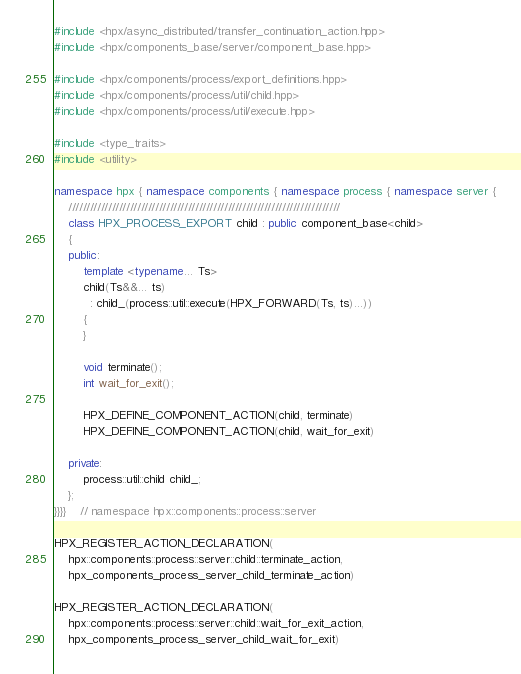Convert code to text. <code><loc_0><loc_0><loc_500><loc_500><_C++_>#include <hpx/async_distributed/transfer_continuation_action.hpp>
#include <hpx/components_base/server/component_base.hpp>

#include <hpx/components/process/export_definitions.hpp>
#include <hpx/components/process/util/child.hpp>
#include <hpx/components/process/util/execute.hpp>

#include <type_traits>
#include <utility>

namespace hpx { namespace components { namespace process { namespace server {
    ///////////////////////////////////////////////////////////////////////////
    class HPX_PROCESS_EXPORT child : public component_base<child>
    {
    public:
        template <typename... Ts>
        child(Ts&&... ts)
          : child_(process::util::execute(HPX_FORWARD(Ts, ts)...))
        {
        }

        void terminate();
        int wait_for_exit();

        HPX_DEFINE_COMPONENT_ACTION(child, terminate)
        HPX_DEFINE_COMPONENT_ACTION(child, wait_for_exit)

    private:
        process::util::child child_;
    };
}}}}    // namespace hpx::components::process::server

HPX_REGISTER_ACTION_DECLARATION(
    hpx::components::process::server::child::terminate_action,
    hpx_components_process_server_child_terminate_action)

HPX_REGISTER_ACTION_DECLARATION(
    hpx::components::process::server::child::wait_for_exit_action,
    hpx_components_process_server_child_wait_for_exit)
</code> 